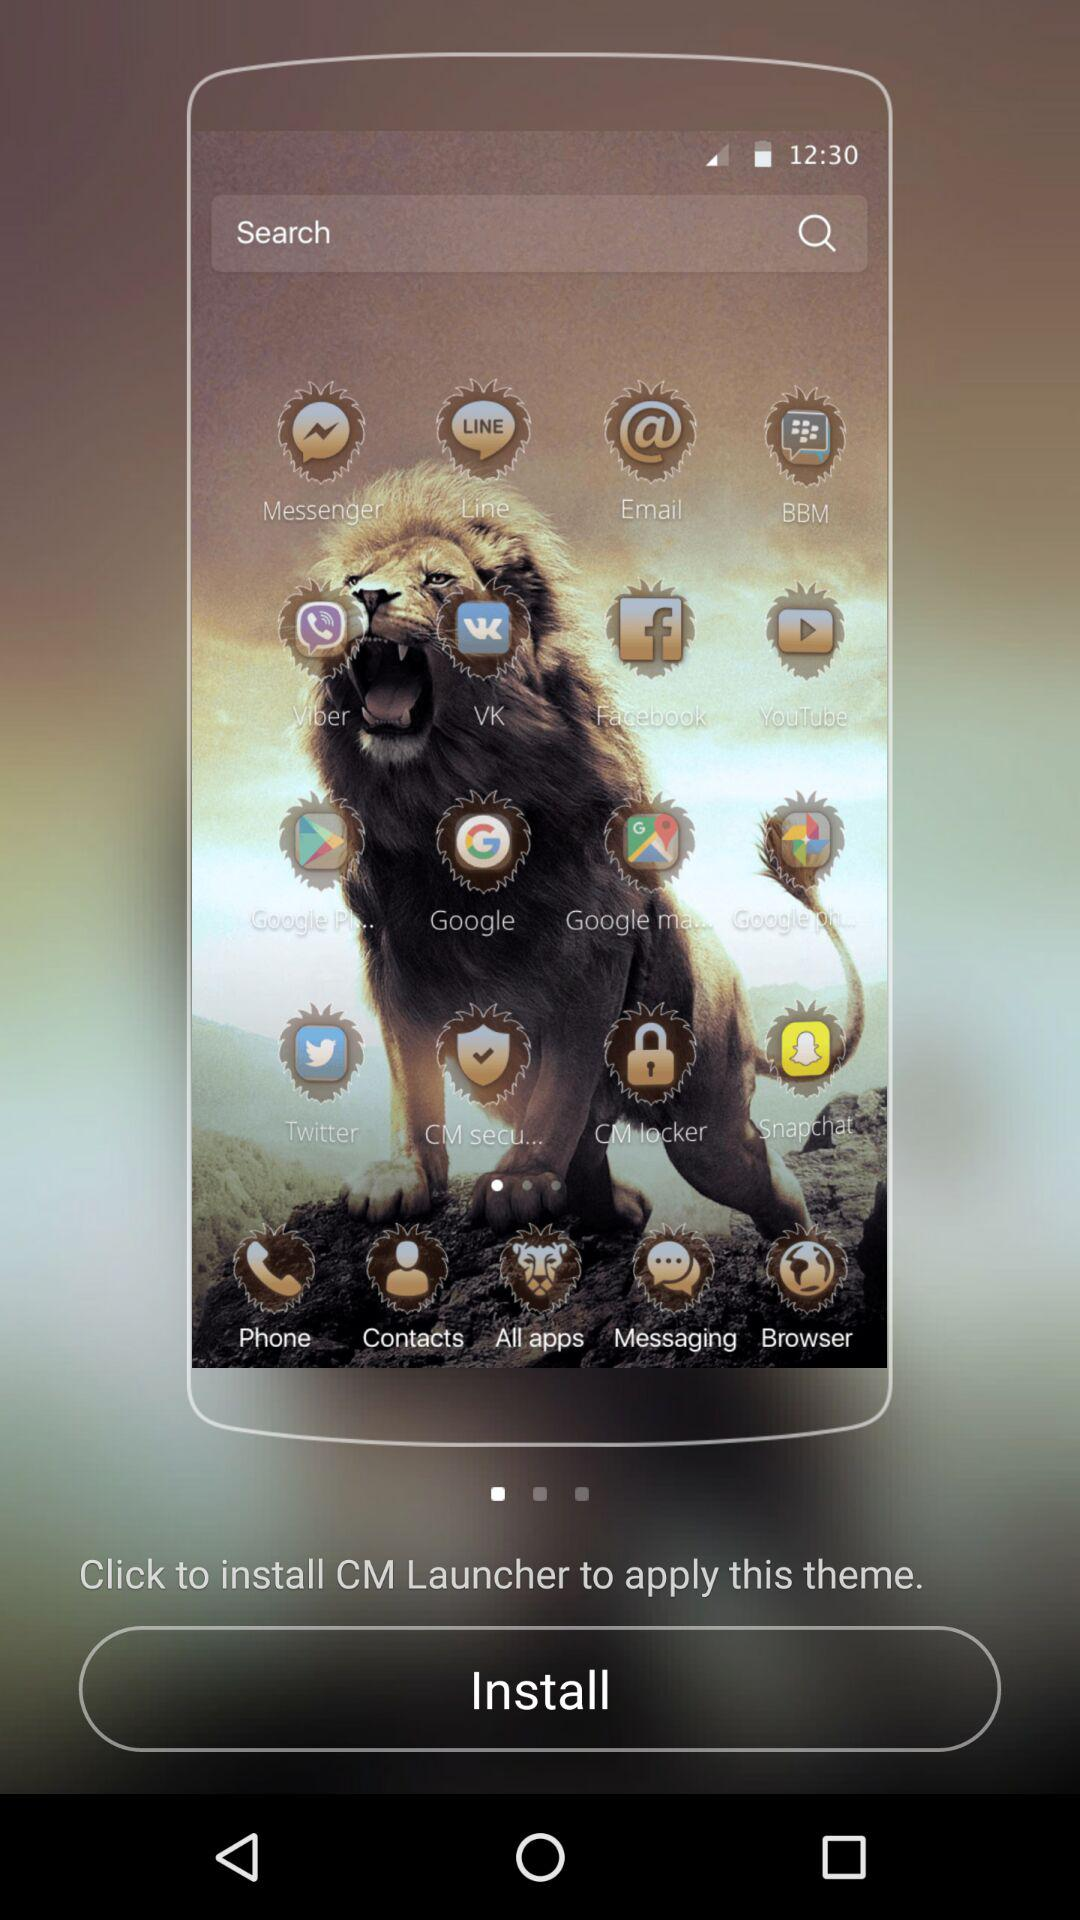Which app can be used for securing the mobile? The apps that can be used for securing the mobile are "CM secu..." and "CM locker". 